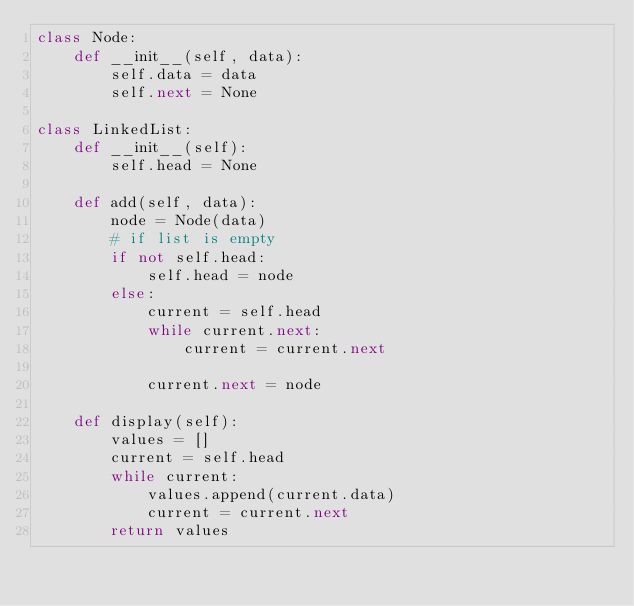<code> <loc_0><loc_0><loc_500><loc_500><_Python_>class Node:
    def __init__(self, data):
        self.data = data 
        self.next = None

class LinkedList:
    def __init__(self):
        self.head = None

    def add(self, data):
        node = Node(data)
        # if list is empty
        if not self.head:
            self.head = node
        else:
            current = self.head
            while current.next:
                current = current.next

            current.next = node

    def display(self):
        values = []
        current = self.head
        while current:
            values.append(current.data)
            current = current.next
        return values    </code> 